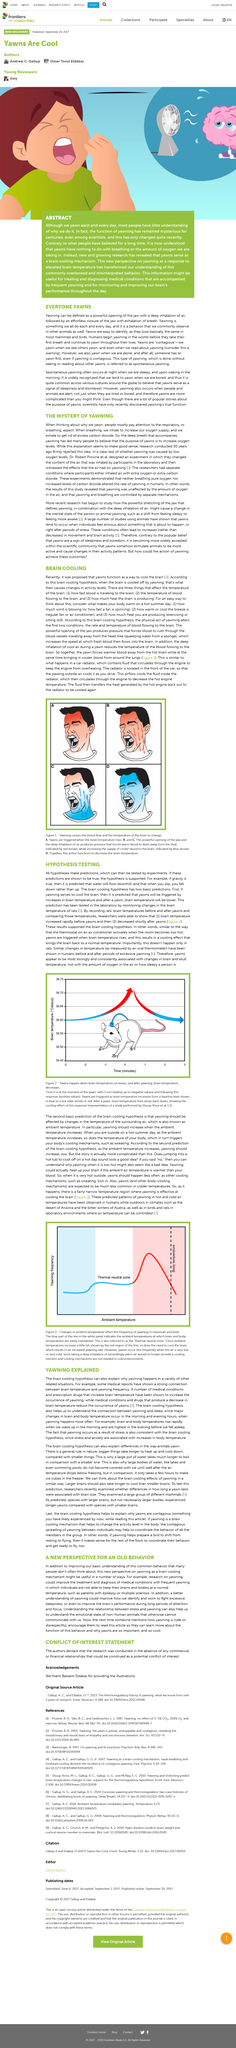Indicate a few pertinent items in this graphic. Some medical reports have shown a correlation between brain temperature and yawning frequency. Stress and anxiety are two factors that are associated with increases in body temperature. Yawning begins in humans before they take their first breath in the womb. The main hypothesis for yawning is that it serves as a mechanism for brain cooling. When someone yawns, they typically take in a deep breath of air. 